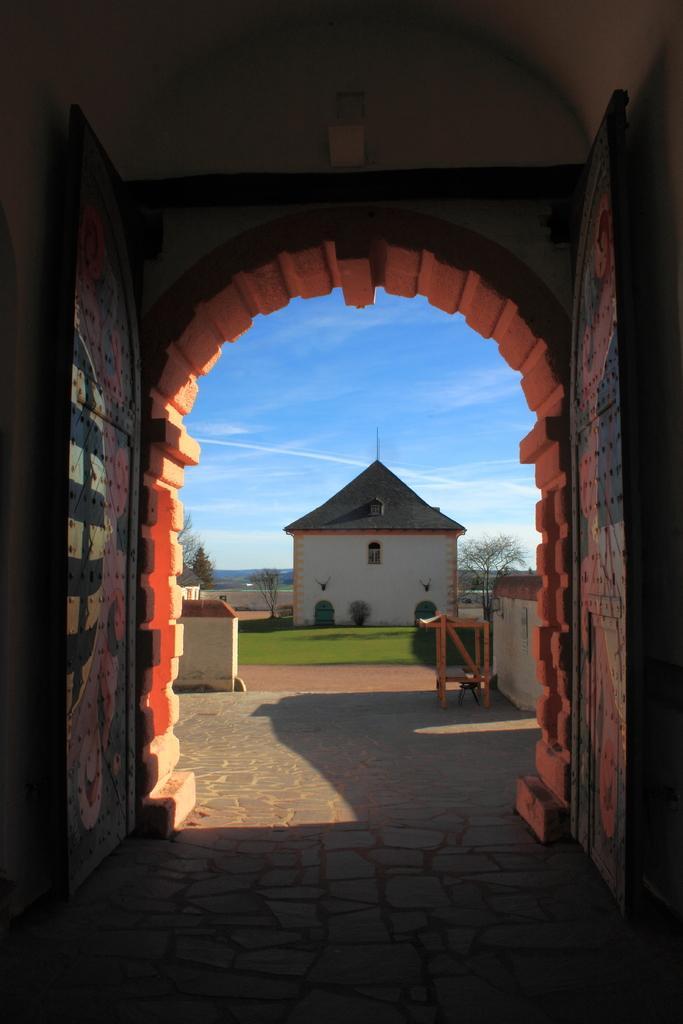Could you give a brief overview of what you see in this image? In this image we can see a door, walls, a building, grass, a few trees and some clouds in the sky. 